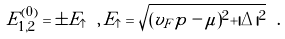<formula> <loc_0><loc_0><loc_500><loc_500>E _ { 1 , 2 } ^ { ( 0 ) } = \pm E _ { \uparrow } \ , \, E _ { \uparrow } = \sqrt { ( v _ { F } p - \mu ) ^ { 2 } + | \Delta | ^ { 2 } } \ .</formula> 